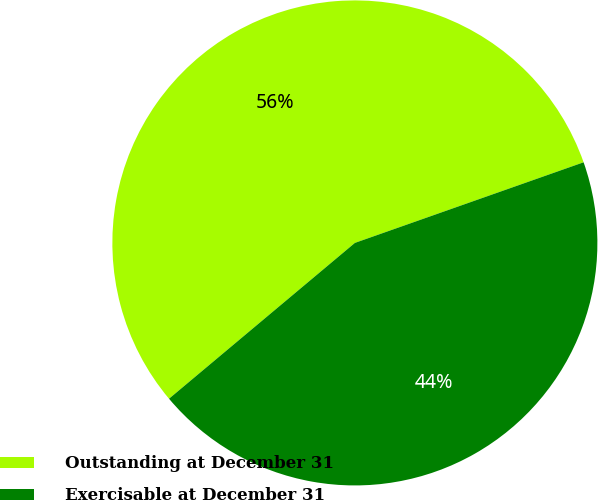Convert chart. <chart><loc_0><loc_0><loc_500><loc_500><pie_chart><fcel>Outstanding at December 31<fcel>Exercisable at December 31<nl><fcel>55.71%<fcel>44.29%<nl></chart> 